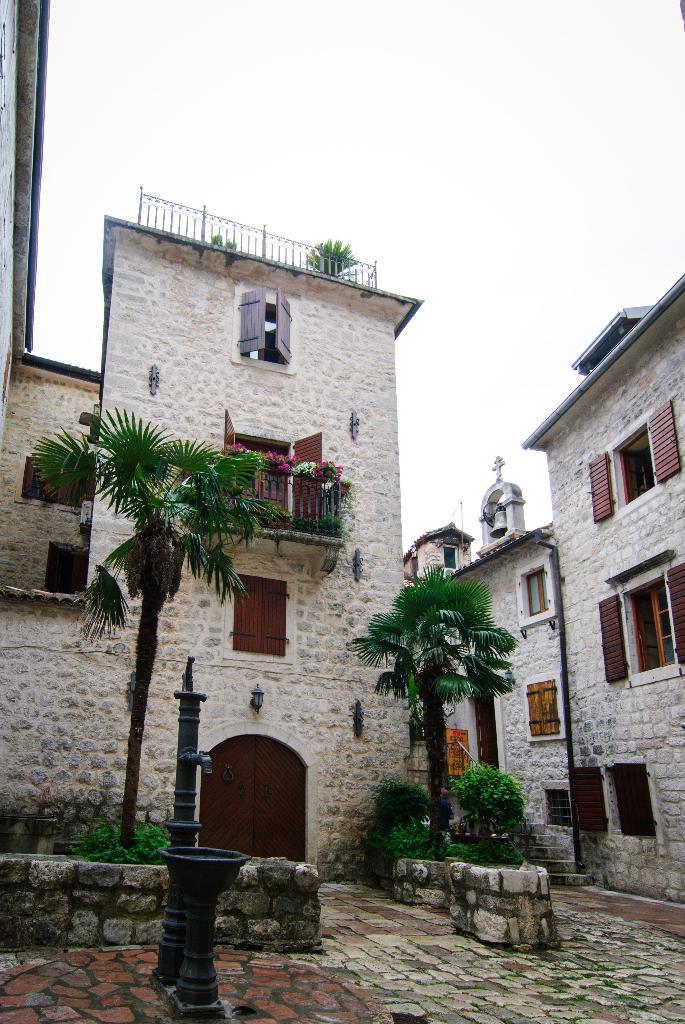Please provide a concise description of this image. In the picture we can see a house building with door, windows and railing to it and near to the building we can see some plants and some show trees on the path beside the building we can see another building with windows to it and in the background we can see a sky. 